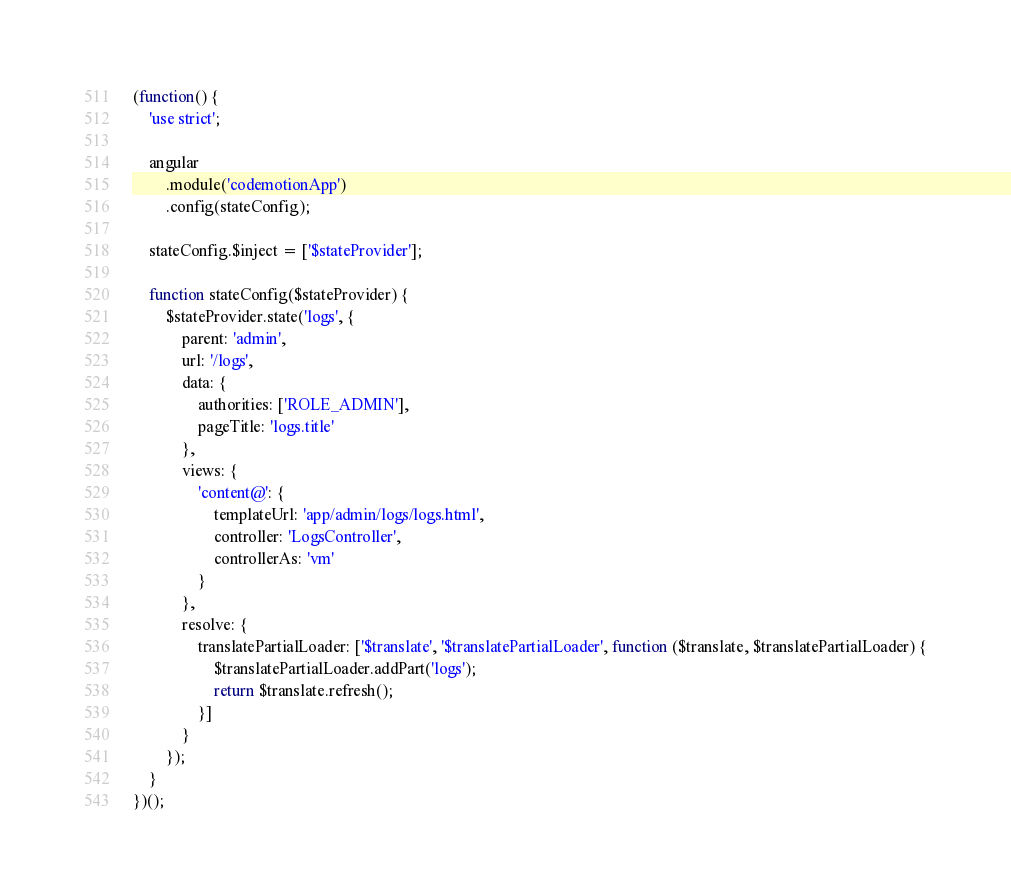Convert code to text. <code><loc_0><loc_0><loc_500><loc_500><_JavaScript_>(function() {
    'use strict';

    angular
        .module('codemotionApp')
        .config(stateConfig);

    stateConfig.$inject = ['$stateProvider'];

    function stateConfig($stateProvider) {
        $stateProvider.state('logs', {
            parent: 'admin',
            url: '/logs',
            data: {
                authorities: ['ROLE_ADMIN'],
                pageTitle: 'logs.title'
            },
            views: {
                'content@': {
                    templateUrl: 'app/admin/logs/logs.html',
                    controller: 'LogsController',
                    controllerAs: 'vm'
                }
            },
            resolve: {
                translatePartialLoader: ['$translate', '$translatePartialLoader', function ($translate, $translatePartialLoader) {
                    $translatePartialLoader.addPart('logs');
                    return $translate.refresh();
                }]
            }
        });
    }
})();
</code> 